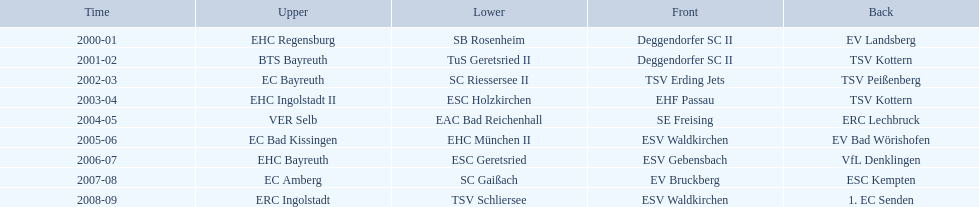Which teams won the north in their respective years? 2000-01, EHC Regensburg, BTS Bayreuth, EC Bayreuth, EHC Ingolstadt II, VER Selb, EC Bad Kissingen, EHC Bayreuth, EC Amberg, ERC Ingolstadt. Which one only won in 2000-01? EHC Regensburg. 